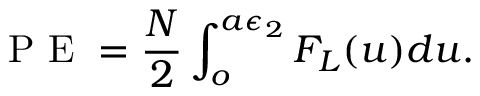Convert formula to latex. <formula><loc_0><loc_0><loc_500><loc_500>P E = \frac { N } { 2 } \int _ { o } ^ { a \epsilon _ { 2 } } F _ { L } ( u ) d u .</formula> 